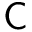Convert formula to latex. <formula><loc_0><loc_0><loc_500><loc_500>\mathsf C</formula> 